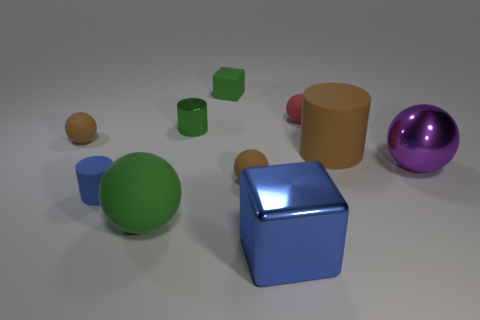There is a small brown object that is left of the green rubber sphere; what material is it?
Your answer should be very brief. Rubber. How many shiny objects are either big blue objects or large purple blocks?
Give a very brief answer. 1. What is the color of the tiny cylinder that is in front of the brown rubber sphere on the left side of the green cylinder?
Your answer should be compact. Blue. Do the purple ball and the tiny cylinder that is on the right side of the big matte sphere have the same material?
Give a very brief answer. Yes. There is a metal thing right of the block that is in front of the large ball in front of the blue rubber cylinder; what is its color?
Provide a short and direct response. Purple. Are there any other things that are the same shape as the large green matte object?
Your answer should be very brief. Yes. Are there more large metal things than objects?
Ensure brevity in your answer.  No. How many large balls are both to the right of the green block and on the left side of the big metal ball?
Provide a short and direct response. 0. How many objects are in front of the large green sphere that is left of the green rubber cube?
Ensure brevity in your answer.  1. There is a brown matte thing on the right side of the shiny cube; does it have the same size as the shiny object on the left side of the tiny matte cube?
Provide a succinct answer. No. 